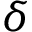<formula> <loc_0><loc_0><loc_500><loc_500>\delta</formula> 